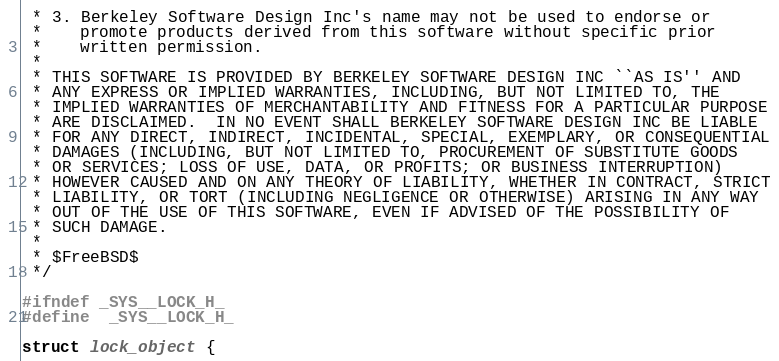<code> <loc_0><loc_0><loc_500><loc_500><_C_> * 3. Berkeley Software Design Inc's name may not be used to endorse or
 *    promote products derived from this software without specific prior
 *    written permission.
 *
 * THIS SOFTWARE IS PROVIDED BY BERKELEY SOFTWARE DESIGN INC ``AS IS'' AND
 * ANY EXPRESS OR IMPLIED WARRANTIES, INCLUDING, BUT NOT LIMITED TO, THE
 * IMPLIED WARRANTIES OF MERCHANTABILITY AND FITNESS FOR A PARTICULAR PURPOSE
 * ARE DISCLAIMED.  IN NO EVENT SHALL BERKELEY SOFTWARE DESIGN INC BE LIABLE
 * FOR ANY DIRECT, INDIRECT, INCIDENTAL, SPECIAL, EXEMPLARY, OR CONSEQUENTIAL
 * DAMAGES (INCLUDING, BUT NOT LIMITED TO, PROCUREMENT OF SUBSTITUTE GOODS
 * OR SERVICES; LOSS OF USE, DATA, OR PROFITS; OR BUSINESS INTERRUPTION)
 * HOWEVER CAUSED AND ON ANY THEORY OF LIABILITY, WHETHER IN CONTRACT, STRICT
 * LIABILITY, OR TORT (INCLUDING NEGLIGENCE OR OTHERWISE) ARISING IN ANY WAY
 * OUT OF THE USE OF THIS SOFTWARE, EVEN IF ADVISED OF THE POSSIBILITY OF
 * SUCH DAMAGE.
 *
 * $FreeBSD$
 */

#ifndef _SYS__LOCK_H_
#define	_SYS__LOCK_H_

struct lock_object {</code> 